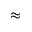<formula> <loc_0><loc_0><loc_500><loc_500>\approx</formula> 